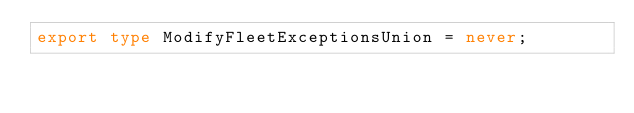Convert code to text. <code><loc_0><loc_0><loc_500><loc_500><_TypeScript_>export type ModifyFleetExceptionsUnion = never;
</code> 